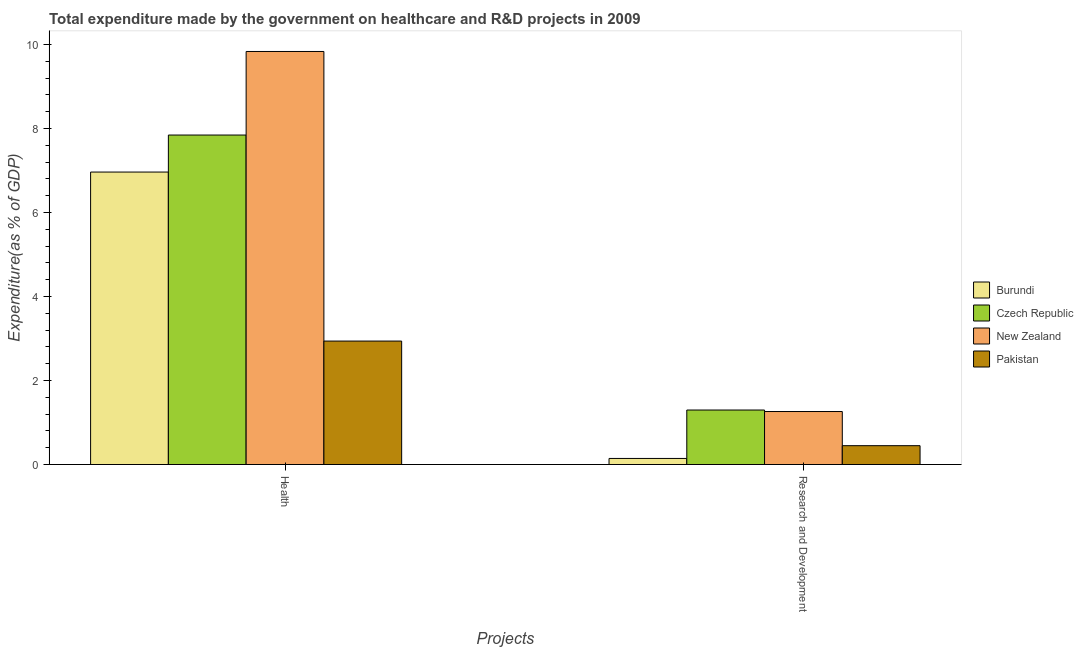How many different coloured bars are there?
Your response must be concise. 4. How many groups of bars are there?
Make the answer very short. 2. Are the number of bars per tick equal to the number of legend labels?
Keep it short and to the point. Yes. How many bars are there on the 2nd tick from the left?
Offer a terse response. 4. How many bars are there on the 1st tick from the right?
Your response must be concise. 4. What is the label of the 2nd group of bars from the left?
Give a very brief answer. Research and Development. What is the expenditure in healthcare in New Zealand?
Provide a short and direct response. 9.84. Across all countries, what is the maximum expenditure in r&d?
Provide a short and direct response. 1.3. Across all countries, what is the minimum expenditure in healthcare?
Offer a very short reply. 2.94. In which country was the expenditure in r&d maximum?
Offer a terse response. Czech Republic. In which country was the expenditure in r&d minimum?
Your answer should be very brief. Burundi. What is the total expenditure in r&d in the graph?
Your answer should be compact. 3.15. What is the difference between the expenditure in healthcare in Pakistan and that in Czech Republic?
Make the answer very short. -4.91. What is the difference between the expenditure in r&d in Pakistan and the expenditure in healthcare in New Zealand?
Keep it short and to the point. -9.39. What is the average expenditure in r&d per country?
Offer a terse response. 0.79. What is the difference between the expenditure in healthcare and expenditure in r&d in New Zealand?
Your answer should be compact. 8.57. What is the ratio of the expenditure in healthcare in Pakistan to that in New Zealand?
Give a very brief answer. 0.3. Is the expenditure in r&d in Czech Republic less than that in Burundi?
Offer a very short reply. No. In how many countries, is the expenditure in r&d greater than the average expenditure in r&d taken over all countries?
Make the answer very short. 2. What does the 2nd bar from the left in Research and Development represents?
Offer a terse response. Czech Republic. Are all the bars in the graph horizontal?
Your answer should be very brief. No. What is the difference between two consecutive major ticks on the Y-axis?
Give a very brief answer. 2. Are the values on the major ticks of Y-axis written in scientific E-notation?
Your response must be concise. No. Does the graph contain any zero values?
Your response must be concise. No. Where does the legend appear in the graph?
Offer a very short reply. Center right. How many legend labels are there?
Ensure brevity in your answer.  4. What is the title of the graph?
Provide a succinct answer. Total expenditure made by the government on healthcare and R&D projects in 2009. What is the label or title of the X-axis?
Offer a very short reply. Projects. What is the label or title of the Y-axis?
Provide a succinct answer. Expenditure(as % of GDP). What is the Expenditure(as % of GDP) of Burundi in Health?
Keep it short and to the point. 6.96. What is the Expenditure(as % of GDP) of Czech Republic in Health?
Offer a terse response. 7.85. What is the Expenditure(as % of GDP) of New Zealand in Health?
Provide a short and direct response. 9.84. What is the Expenditure(as % of GDP) in Pakistan in Health?
Ensure brevity in your answer.  2.94. What is the Expenditure(as % of GDP) in Burundi in Research and Development?
Provide a short and direct response. 0.14. What is the Expenditure(as % of GDP) of Czech Republic in Research and Development?
Offer a very short reply. 1.3. What is the Expenditure(as % of GDP) in New Zealand in Research and Development?
Offer a terse response. 1.26. What is the Expenditure(as % of GDP) in Pakistan in Research and Development?
Offer a very short reply. 0.45. Across all Projects, what is the maximum Expenditure(as % of GDP) of Burundi?
Provide a succinct answer. 6.96. Across all Projects, what is the maximum Expenditure(as % of GDP) of Czech Republic?
Ensure brevity in your answer.  7.85. Across all Projects, what is the maximum Expenditure(as % of GDP) in New Zealand?
Offer a very short reply. 9.84. Across all Projects, what is the maximum Expenditure(as % of GDP) in Pakistan?
Ensure brevity in your answer.  2.94. Across all Projects, what is the minimum Expenditure(as % of GDP) in Burundi?
Make the answer very short. 0.14. Across all Projects, what is the minimum Expenditure(as % of GDP) in Czech Republic?
Ensure brevity in your answer.  1.3. Across all Projects, what is the minimum Expenditure(as % of GDP) of New Zealand?
Offer a terse response. 1.26. Across all Projects, what is the minimum Expenditure(as % of GDP) of Pakistan?
Offer a very short reply. 0.45. What is the total Expenditure(as % of GDP) in Burundi in the graph?
Your answer should be very brief. 7.11. What is the total Expenditure(as % of GDP) in Czech Republic in the graph?
Your answer should be very brief. 9.14. What is the total Expenditure(as % of GDP) of New Zealand in the graph?
Your answer should be compact. 11.1. What is the total Expenditure(as % of GDP) in Pakistan in the graph?
Provide a succinct answer. 3.39. What is the difference between the Expenditure(as % of GDP) of Burundi in Health and that in Research and Development?
Your answer should be very brief. 6.82. What is the difference between the Expenditure(as % of GDP) of Czech Republic in Health and that in Research and Development?
Provide a short and direct response. 6.55. What is the difference between the Expenditure(as % of GDP) of New Zealand in Health and that in Research and Development?
Give a very brief answer. 8.57. What is the difference between the Expenditure(as % of GDP) in Pakistan in Health and that in Research and Development?
Provide a short and direct response. 2.49. What is the difference between the Expenditure(as % of GDP) in Burundi in Health and the Expenditure(as % of GDP) in Czech Republic in Research and Development?
Your answer should be very brief. 5.67. What is the difference between the Expenditure(as % of GDP) in Burundi in Health and the Expenditure(as % of GDP) in New Zealand in Research and Development?
Offer a very short reply. 5.7. What is the difference between the Expenditure(as % of GDP) of Burundi in Health and the Expenditure(as % of GDP) of Pakistan in Research and Development?
Provide a succinct answer. 6.52. What is the difference between the Expenditure(as % of GDP) of Czech Republic in Health and the Expenditure(as % of GDP) of New Zealand in Research and Development?
Provide a short and direct response. 6.58. What is the difference between the Expenditure(as % of GDP) of Czech Republic in Health and the Expenditure(as % of GDP) of Pakistan in Research and Development?
Make the answer very short. 7.4. What is the difference between the Expenditure(as % of GDP) in New Zealand in Health and the Expenditure(as % of GDP) in Pakistan in Research and Development?
Your answer should be compact. 9.39. What is the average Expenditure(as % of GDP) of Burundi per Projects?
Ensure brevity in your answer.  3.55. What is the average Expenditure(as % of GDP) in Czech Republic per Projects?
Keep it short and to the point. 4.57. What is the average Expenditure(as % of GDP) of New Zealand per Projects?
Provide a short and direct response. 5.55. What is the average Expenditure(as % of GDP) in Pakistan per Projects?
Give a very brief answer. 1.69. What is the difference between the Expenditure(as % of GDP) of Burundi and Expenditure(as % of GDP) of Czech Republic in Health?
Your answer should be compact. -0.88. What is the difference between the Expenditure(as % of GDP) in Burundi and Expenditure(as % of GDP) in New Zealand in Health?
Offer a terse response. -2.87. What is the difference between the Expenditure(as % of GDP) in Burundi and Expenditure(as % of GDP) in Pakistan in Health?
Your response must be concise. 4.03. What is the difference between the Expenditure(as % of GDP) in Czech Republic and Expenditure(as % of GDP) in New Zealand in Health?
Ensure brevity in your answer.  -1.99. What is the difference between the Expenditure(as % of GDP) of Czech Republic and Expenditure(as % of GDP) of Pakistan in Health?
Provide a succinct answer. 4.91. What is the difference between the Expenditure(as % of GDP) of New Zealand and Expenditure(as % of GDP) of Pakistan in Health?
Give a very brief answer. 6.9. What is the difference between the Expenditure(as % of GDP) of Burundi and Expenditure(as % of GDP) of Czech Republic in Research and Development?
Make the answer very short. -1.15. What is the difference between the Expenditure(as % of GDP) in Burundi and Expenditure(as % of GDP) in New Zealand in Research and Development?
Provide a short and direct response. -1.12. What is the difference between the Expenditure(as % of GDP) in Burundi and Expenditure(as % of GDP) in Pakistan in Research and Development?
Make the answer very short. -0.3. What is the difference between the Expenditure(as % of GDP) of Czech Republic and Expenditure(as % of GDP) of New Zealand in Research and Development?
Ensure brevity in your answer.  0.04. What is the difference between the Expenditure(as % of GDP) of Czech Republic and Expenditure(as % of GDP) of Pakistan in Research and Development?
Make the answer very short. 0.85. What is the difference between the Expenditure(as % of GDP) in New Zealand and Expenditure(as % of GDP) in Pakistan in Research and Development?
Your answer should be very brief. 0.81. What is the ratio of the Expenditure(as % of GDP) of Burundi in Health to that in Research and Development?
Give a very brief answer. 48.25. What is the ratio of the Expenditure(as % of GDP) of Czech Republic in Health to that in Research and Development?
Give a very brief answer. 6.05. What is the ratio of the Expenditure(as % of GDP) of New Zealand in Health to that in Research and Development?
Provide a succinct answer. 7.8. What is the ratio of the Expenditure(as % of GDP) of Pakistan in Health to that in Research and Development?
Provide a succinct answer. 6.56. What is the difference between the highest and the second highest Expenditure(as % of GDP) of Burundi?
Keep it short and to the point. 6.82. What is the difference between the highest and the second highest Expenditure(as % of GDP) of Czech Republic?
Give a very brief answer. 6.55. What is the difference between the highest and the second highest Expenditure(as % of GDP) of New Zealand?
Provide a short and direct response. 8.57. What is the difference between the highest and the second highest Expenditure(as % of GDP) of Pakistan?
Offer a terse response. 2.49. What is the difference between the highest and the lowest Expenditure(as % of GDP) of Burundi?
Your answer should be compact. 6.82. What is the difference between the highest and the lowest Expenditure(as % of GDP) of Czech Republic?
Keep it short and to the point. 6.55. What is the difference between the highest and the lowest Expenditure(as % of GDP) of New Zealand?
Offer a very short reply. 8.57. What is the difference between the highest and the lowest Expenditure(as % of GDP) in Pakistan?
Keep it short and to the point. 2.49. 